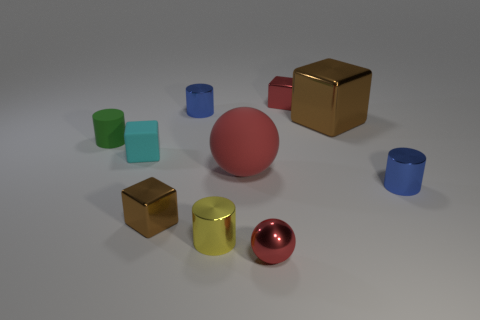Subtract all metal cylinders. How many cylinders are left? 1 Subtract all yellow cylinders. How many cylinders are left? 3 Subtract 2 blocks. How many blocks are left? 2 Subtract all balls. How many objects are left? 8 Subtract all blue spheres. How many red blocks are left? 1 Add 7 large purple rubber blocks. How many large purple rubber blocks exist? 7 Subtract 0 purple balls. How many objects are left? 10 Subtract all green cylinders. Subtract all blue balls. How many cylinders are left? 3 Subtract all small metallic balls. Subtract all small green rubber cylinders. How many objects are left? 8 Add 5 small blue metallic things. How many small blue metallic things are left? 7 